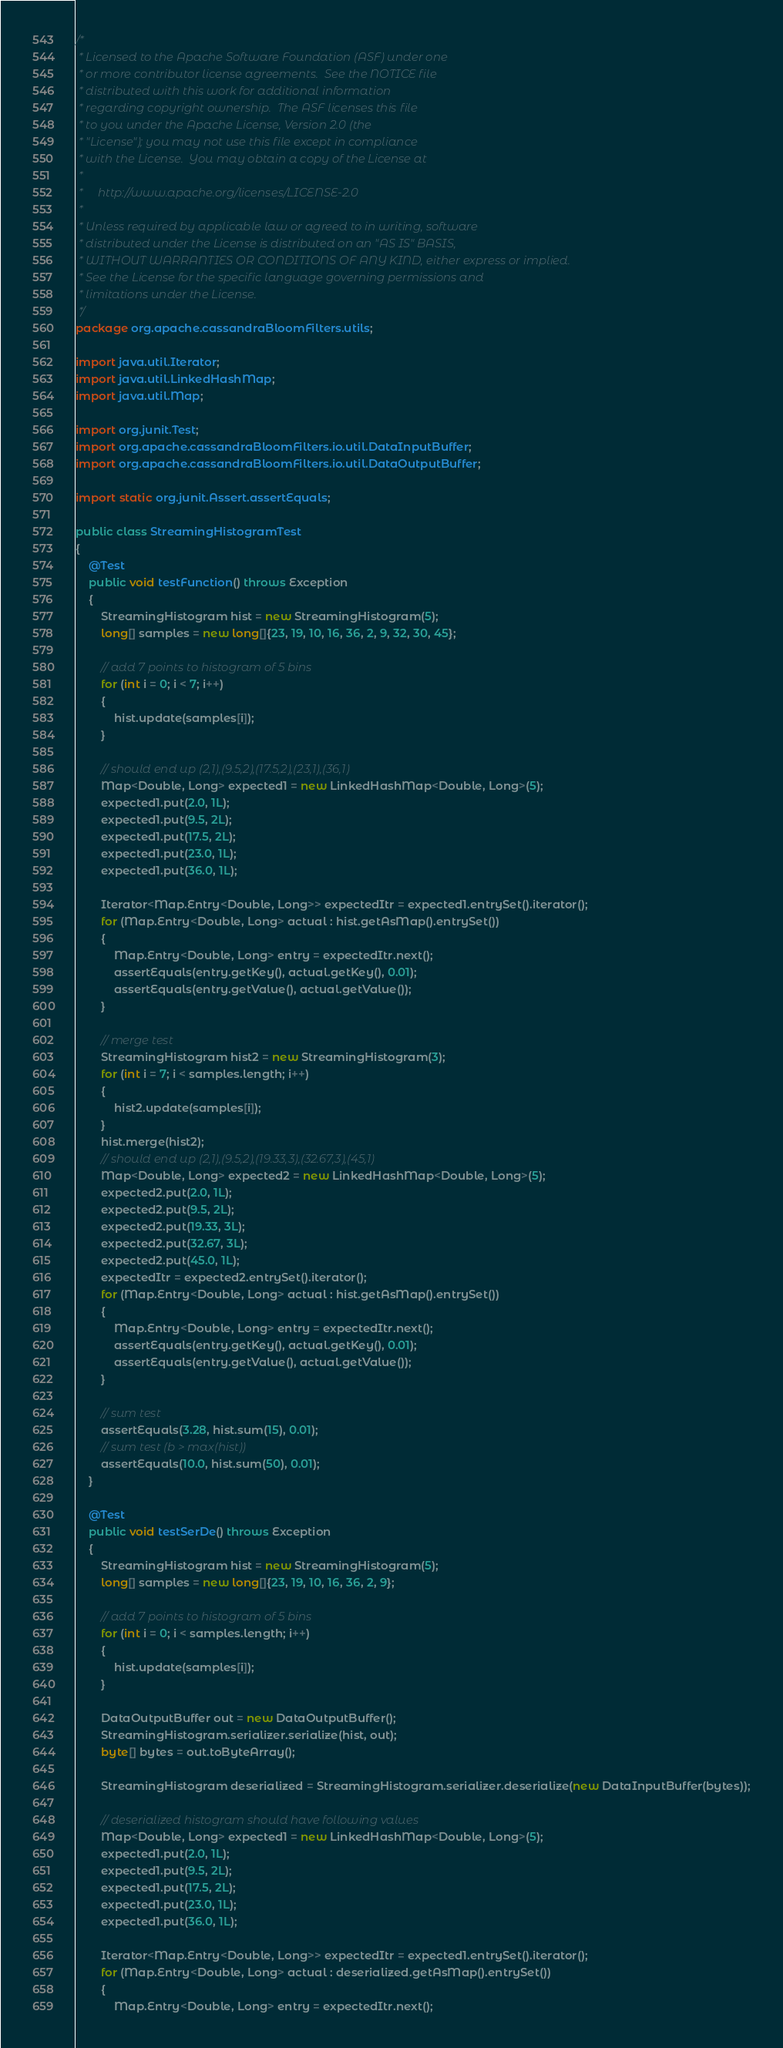<code> <loc_0><loc_0><loc_500><loc_500><_Java_>/*
 * Licensed to the Apache Software Foundation (ASF) under one
 * or more contributor license agreements.  See the NOTICE file
 * distributed with this work for additional information
 * regarding copyright ownership.  The ASF licenses this file
 * to you under the Apache License, Version 2.0 (the
 * "License"); you may not use this file except in compliance
 * with the License.  You may obtain a copy of the License at
 *
 *     http://www.apache.org/licenses/LICENSE-2.0
 *
 * Unless required by applicable law or agreed to in writing, software
 * distributed under the License is distributed on an "AS IS" BASIS,
 * WITHOUT WARRANTIES OR CONDITIONS OF ANY KIND, either express or implied.
 * See the License for the specific language governing permissions and
 * limitations under the License.
 */
package org.apache.cassandraBloomFilters.utils;

import java.util.Iterator;
import java.util.LinkedHashMap;
import java.util.Map;

import org.junit.Test;
import org.apache.cassandraBloomFilters.io.util.DataInputBuffer;
import org.apache.cassandraBloomFilters.io.util.DataOutputBuffer;

import static org.junit.Assert.assertEquals;

public class StreamingHistogramTest
{
    @Test
    public void testFunction() throws Exception
    {
        StreamingHistogram hist = new StreamingHistogram(5);
        long[] samples = new long[]{23, 19, 10, 16, 36, 2, 9, 32, 30, 45};

        // add 7 points to histogram of 5 bins
        for (int i = 0; i < 7; i++)
        {
            hist.update(samples[i]);
        }

        // should end up (2,1),(9.5,2),(17.5,2),(23,1),(36,1)
        Map<Double, Long> expected1 = new LinkedHashMap<Double, Long>(5);
        expected1.put(2.0, 1L);
        expected1.put(9.5, 2L);
        expected1.put(17.5, 2L);
        expected1.put(23.0, 1L);
        expected1.put(36.0, 1L);

        Iterator<Map.Entry<Double, Long>> expectedItr = expected1.entrySet().iterator();
        for (Map.Entry<Double, Long> actual : hist.getAsMap().entrySet())
        {
            Map.Entry<Double, Long> entry = expectedItr.next();
            assertEquals(entry.getKey(), actual.getKey(), 0.01);
            assertEquals(entry.getValue(), actual.getValue());
        }

        // merge test
        StreamingHistogram hist2 = new StreamingHistogram(3);
        for (int i = 7; i < samples.length; i++)
        {
            hist2.update(samples[i]);
        }
        hist.merge(hist2);
        // should end up (2,1),(9.5,2),(19.33,3),(32.67,3),(45,1)
        Map<Double, Long> expected2 = new LinkedHashMap<Double, Long>(5);
        expected2.put(2.0, 1L);
        expected2.put(9.5, 2L);
        expected2.put(19.33, 3L);
        expected2.put(32.67, 3L);
        expected2.put(45.0, 1L);
        expectedItr = expected2.entrySet().iterator();
        for (Map.Entry<Double, Long> actual : hist.getAsMap().entrySet())
        {
            Map.Entry<Double, Long> entry = expectedItr.next();
            assertEquals(entry.getKey(), actual.getKey(), 0.01);
            assertEquals(entry.getValue(), actual.getValue());
        }

        // sum test
        assertEquals(3.28, hist.sum(15), 0.01);
        // sum test (b > max(hist))
        assertEquals(10.0, hist.sum(50), 0.01);
    }

    @Test
    public void testSerDe() throws Exception
    {
        StreamingHistogram hist = new StreamingHistogram(5);
        long[] samples = new long[]{23, 19, 10, 16, 36, 2, 9};

        // add 7 points to histogram of 5 bins
        for (int i = 0; i < samples.length; i++)
        {
            hist.update(samples[i]);
        }

        DataOutputBuffer out = new DataOutputBuffer();
        StreamingHistogram.serializer.serialize(hist, out);
        byte[] bytes = out.toByteArray();

        StreamingHistogram deserialized = StreamingHistogram.serializer.deserialize(new DataInputBuffer(bytes));

        // deserialized histogram should have following values
        Map<Double, Long> expected1 = new LinkedHashMap<Double, Long>(5);
        expected1.put(2.0, 1L);
        expected1.put(9.5, 2L);
        expected1.put(17.5, 2L);
        expected1.put(23.0, 1L);
        expected1.put(36.0, 1L);

        Iterator<Map.Entry<Double, Long>> expectedItr = expected1.entrySet().iterator();
        for (Map.Entry<Double, Long> actual : deserialized.getAsMap().entrySet())
        {
            Map.Entry<Double, Long> entry = expectedItr.next();</code> 